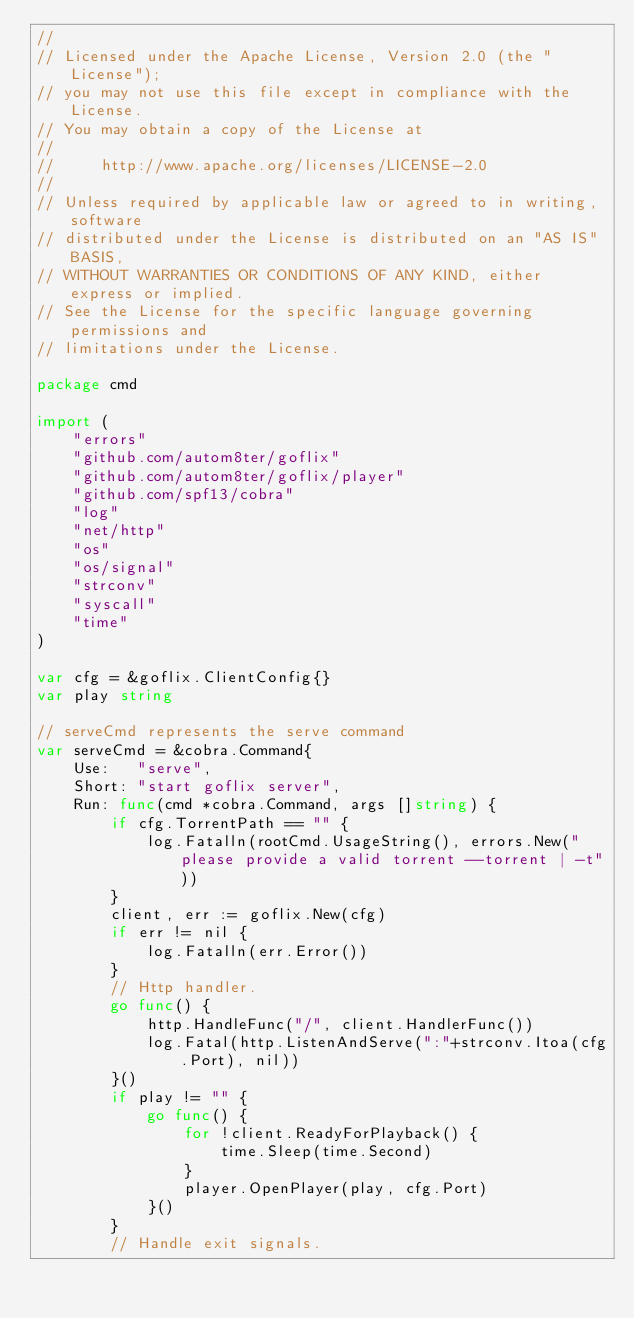<code> <loc_0><loc_0><loc_500><loc_500><_Go_>//
// Licensed under the Apache License, Version 2.0 (the "License");
// you may not use this file except in compliance with the License.
// You may obtain a copy of the License at
//
//     http://www.apache.org/licenses/LICENSE-2.0
//
// Unless required by applicable law or agreed to in writing, software
// distributed under the License is distributed on an "AS IS" BASIS,
// WITHOUT WARRANTIES OR CONDITIONS OF ANY KIND, either express or implied.
// See the License for the specific language governing permissions and
// limitations under the License.

package cmd

import (
	"errors"
	"github.com/autom8ter/goflix"
	"github.com/autom8ter/goflix/player"
	"github.com/spf13/cobra"
	"log"
	"net/http"
	"os"
	"os/signal"
	"strconv"
	"syscall"
	"time"
)

var cfg = &goflix.ClientConfig{}
var play string

// serveCmd represents the serve command
var serveCmd = &cobra.Command{
	Use:   "serve",
	Short: "start goflix server",
	Run: func(cmd *cobra.Command, args []string) {
		if cfg.TorrentPath == "" {
			log.Fatalln(rootCmd.UsageString(), errors.New("please provide a valid torrent --torrent | -t"))
		}
		client, err := goflix.New(cfg)
		if err != nil {
			log.Fatalln(err.Error())
		}
		// Http handler.
		go func() {
			http.HandleFunc("/", client.HandlerFunc())
			log.Fatal(http.ListenAndServe(":"+strconv.Itoa(cfg.Port), nil))
		}()
		if play != "" {
			go func() {
				for !client.ReadyForPlayback() {
					time.Sleep(time.Second)
				}
				player.OpenPlayer(play, cfg.Port)
			}()
		}
		// Handle exit signals.</code> 